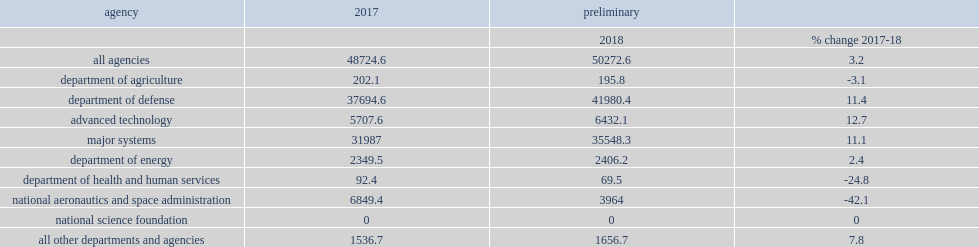What was the share of obligations for experimental development? 0.773626. What was the dod's share of experimental development obligations increased of the estimated fy 2018 total? 0.835055. How many million dollars was nasa's experimental development obligations in fy 2017? 6849.4. How many million dollars was nasa's experimental development obligations in fy 2018? 3964.0. How many percent of total experimental development did nasa account for in fy 2017? 0.140574. How many percent of total experimental development did nasa account for in fy 2018? 0.07885. Which agency had the third-largest amount of federal obligations for experimental development, and its share of total experimental development remained constant from fy 2017 to fy 2018 at 4.8%? Department of energy. 